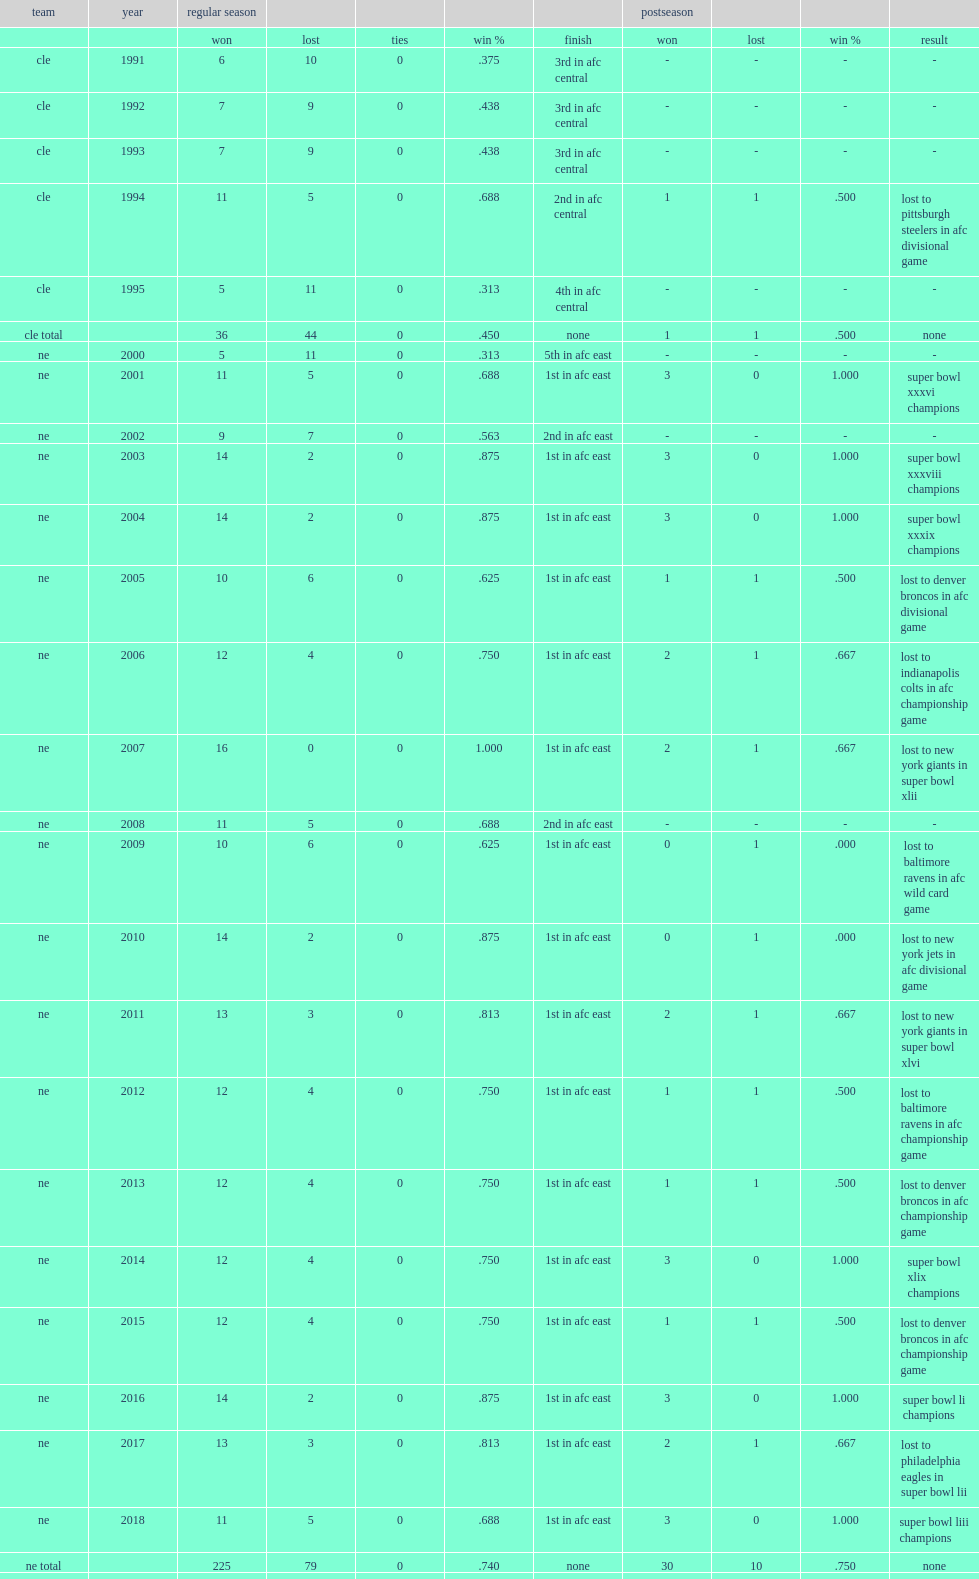In total, how many games did belichick win in the regular season? 261.0. 